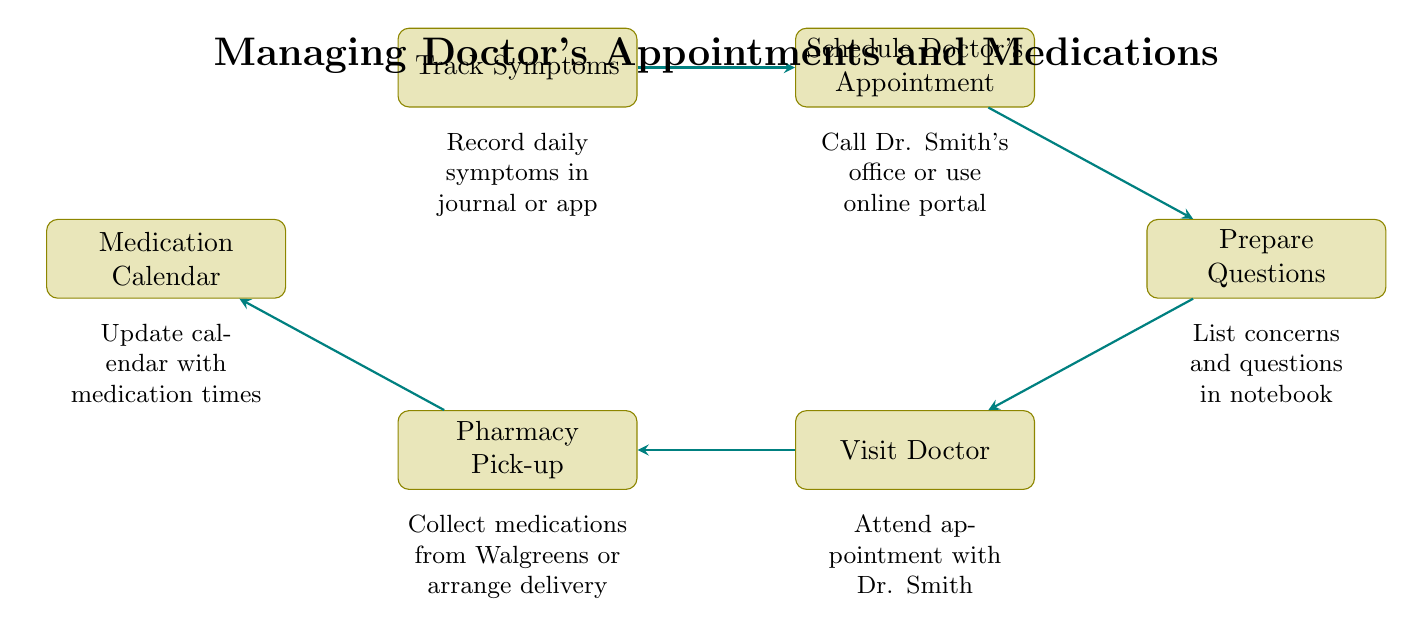What is the first step in the flow chart? The first step is "Track Symptoms," which is indicated as the top node in the flowchart. It starts the process of managing doctor's appointments and medications.
Answer: Track Symptoms How many nodes are there in the diagram? The diagram consists of six nodes, each representing a distinct step in the process of managing appointments and medications.
Answer: 6 What step comes after "Prepare Questions"? The step that comes after "Prepare Questions" is "Visit Doctor," which is connected directly below the "Prepare Questions" node in the flow.
Answer: Visit Doctor Which node is directly linked to "Pharmacy Pick-up"? "Pharmacy Pick-up" is directly linked from "Visit Doctor," as indicated by the arrow connecting these two nodes in the flowchart.
Answer: Visit Doctor What is recorded in the "Track Symptoms" step? In the "Track Symptoms" step, daily symptoms are recorded in a journal or app, as described under the node.
Answer: Daily symptoms How many edges are present in the diagram? The diagram contains five edges, which represent the connections or flow between the six nodes in the process.
Answer: 5 If you have visited the doctor, what is the next action to take? After visiting the doctor, the next action to take is to pick up medications at the pharmacy, as indicated by the flow connecting these two steps.
Answer: Pharmacy Pick-up What are the two pharmacies mentioned in the diagram? The diagram mentions "Walgreens" as the primary pharmacy option, and it implies the possibility of arranging delivery without naming a second pharmacy. Since only one specific pharmacy is mentioned, the answer is Walgreens.
Answer: Walgreens What does the "Medication Calendar" step entail? The "Medication Calendar" step involves updating the calendar with medication times to ensure timely medication management, as described in the node's explanation.
Answer: Update calendar with medication times 